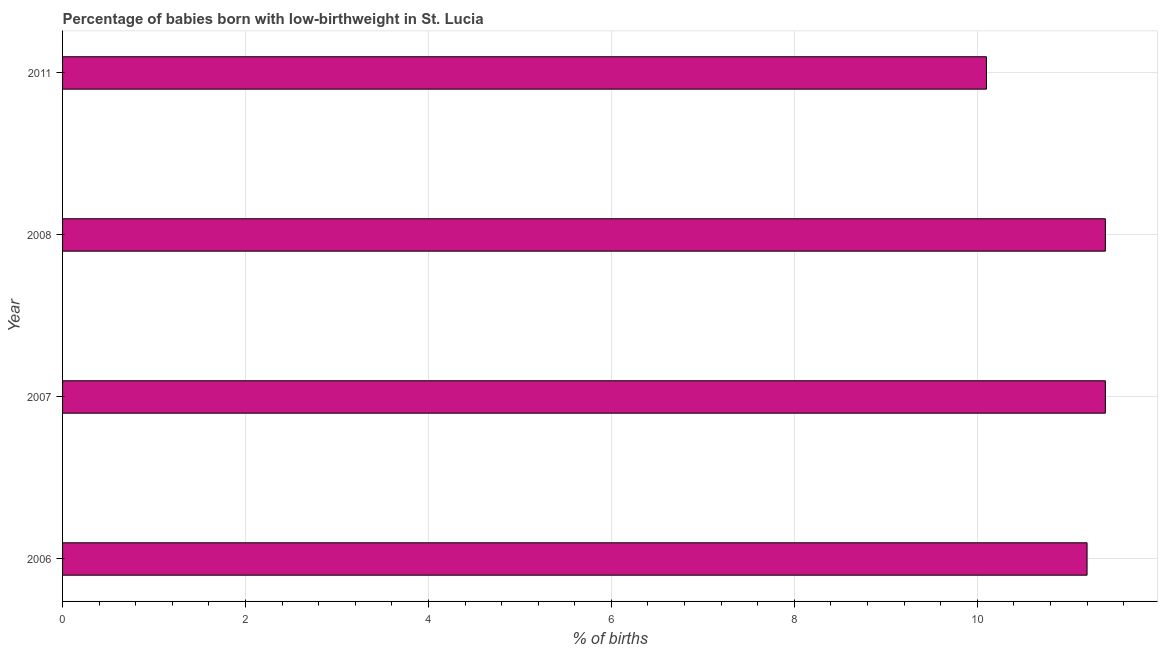What is the title of the graph?
Make the answer very short. Percentage of babies born with low-birthweight in St. Lucia. What is the label or title of the X-axis?
Your response must be concise. % of births. What is the percentage of babies who were born with low-birthweight in 2006?
Make the answer very short. 11.2. Across all years, what is the minimum percentage of babies who were born with low-birthweight?
Provide a short and direct response. 10.1. In which year was the percentage of babies who were born with low-birthweight maximum?
Ensure brevity in your answer.  2007. In which year was the percentage of babies who were born with low-birthweight minimum?
Keep it short and to the point. 2011. What is the sum of the percentage of babies who were born with low-birthweight?
Make the answer very short. 44.1. What is the difference between the percentage of babies who were born with low-birthweight in 2007 and 2011?
Your answer should be compact. 1.3. What is the average percentage of babies who were born with low-birthweight per year?
Make the answer very short. 11.03. In how many years, is the percentage of babies who were born with low-birthweight greater than 6.8 %?
Provide a succinct answer. 4. Do a majority of the years between 2011 and 2006 (inclusive) have percentage of babies who were born with low-birthweight greater than 7.2 %?
Make the answer very short. Yes. Is the sum of the percentage of babies who were born with low-birthweight in 2007 and 2011 greater than the maximum percentage of babies who were born with low-birthweight across all years?
Ensure brevity in your answer.  Yes. What is the difference between the highest and the lowest percentage of babies who were born with low-birthweight?
Provide a succinct answer. 1.3. Are all the bars in the graph horizontal?
Your answer should be compact. Yes. Are the values on the major ticks of X-axis written in scientific E-notation?
Give a very brief answer. No. What is the % of births of 2007?
Offer a very short reply. 11.4. What is the % of births in 2011?
Your response must be concise. 10.1. What is the difference between the % of births in 2006 and 2007?
Make the answer very short. -0.2. What is the difference between the % of births in 2006 and 2008?
Your response must be concise. -0.2. What is the difference between the % of births in 2007 and 2008?
Your response must be concise. 0. What is the ratio of the % of births in 2006 to that in 2011?
Make the answer very short. 1.11. What is the ratio of the % of births in 2007 to that in 2011?
Offer a very short reply. 1.13. What is the ratio of the % of births in 2008 to that in 2011?
Your answer should be compact. 1.13. 